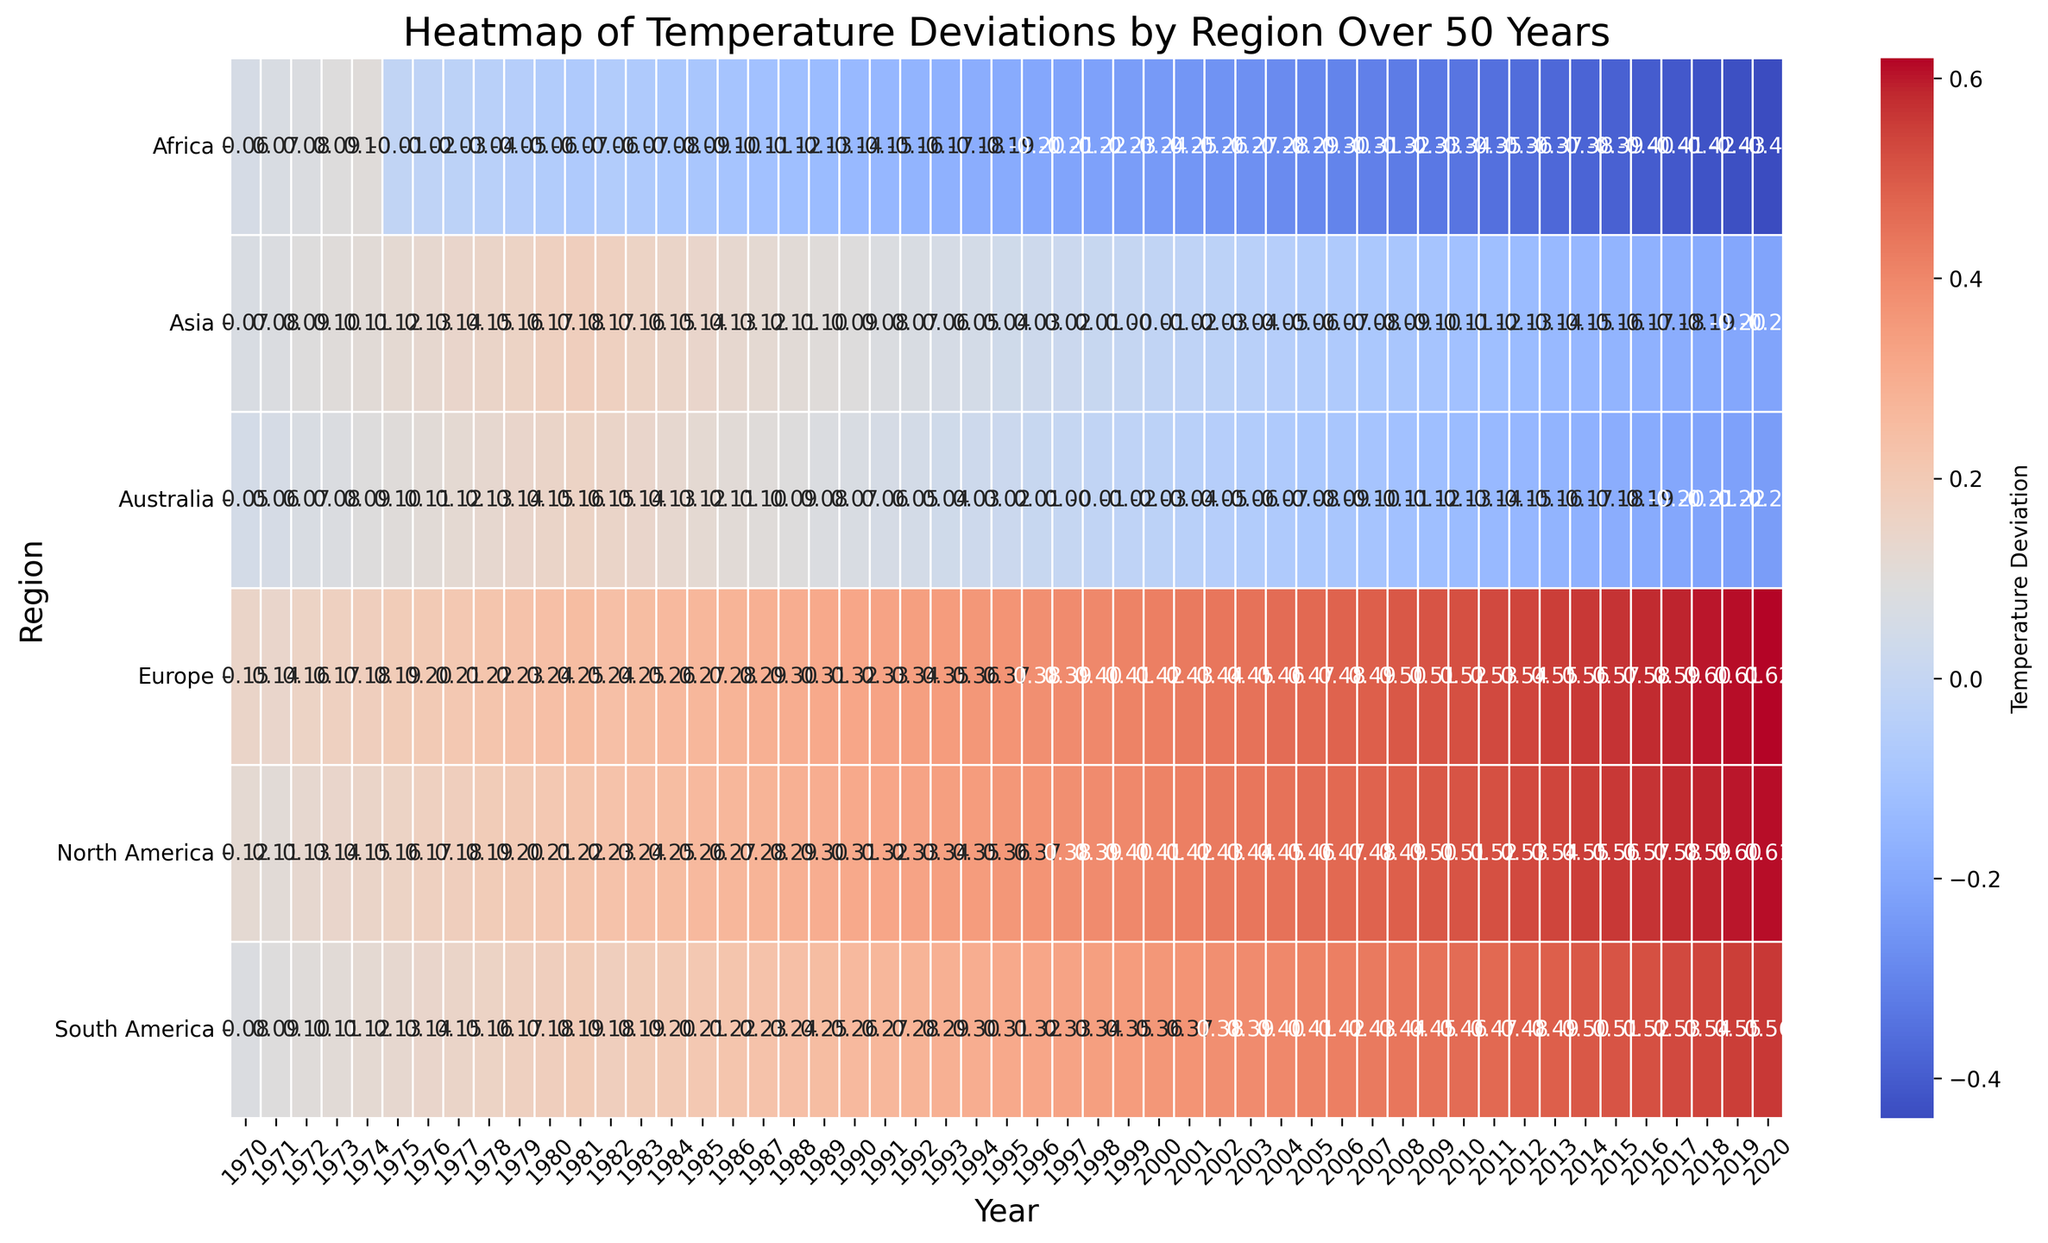What year had the highest overall temperature deviation in Europe? By looking at the heatmap, you can identify the year when Europe shows the deepest red (indicating the highest temperature deviation). This year can be located on the x-axis aligned with the darkest red hue in the Europe row.
Answer: 2020 Which region had the lowest temperature deviation in 1975? By examining the column for the year 1975, find the square with the bluest hue (indicating the lowest temperature deviation). The corresponding row label will be the region with the lowest deviation in 1975.
Answer: Africa What is the average temperature deviation in Asia over the 50 years shown? To find the average, sum all the temperature deviations for Asia and then divide by the number of years (50). Identify and add up the numerical values for Asia and calculate the mean. The numbers are: 0.07, 0.08, 0.09, 0.10, 0.11, 0.12, 0.13, 0.14, 0.15, 0.16, 0.17, 0.18, 0.17, 0.16, 0.15, 0.14, 0.13, 0.12, 0.11, 0.10, 0.09, 0.08, 0.07, 0.06, 0.05, 0.04, 0.03, 0.02, 0.01, 0.00, -0.01, -0.02, -0.03, -0.04, -0.05, -0.06, -0.07, -0.08, -0.09, -0.10, -0.11, -0.12, -0.13, -0.14, -0.15, -0.16, -0.17, -0.18, -0.19, -0.20. The sum is 0.75. The average is 0.75 / 50 = 0.015.
Answer: 0.015 How many regions had negative temperature deviations in 2000? Check the column for the year 2000 and count all the blue hues, which represent negative values. There are three blue squares in the 2000 column, which means there are three regions with negative temperature deviations.
Answer: 3 Which year marked the start of a consistent negative temperature deviation for Africa? Identify the first year in the Africa row where the color turns blue and remains consistently blue in the subsequent years. This is the starting year for consistent negative deviations. In 1975, Africa shows the first negative temperature deviation (light blue), and it continues in subsequent years.
Answer: 1975 